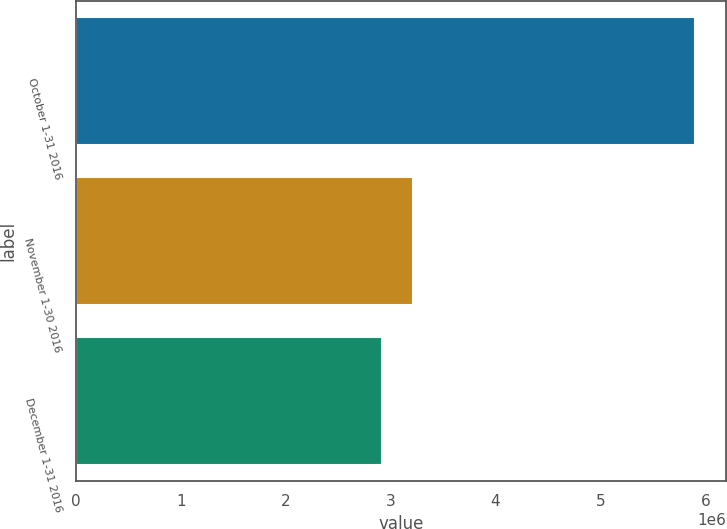Convert chart. <chart><loc_0><loc_0><loc_500><loc_500><bar_chart><fcel>October 1-31 2016<fcel>November 1-30 2016<fcel>December 1-31 2016<nl><fcel>5.90257e+06<fcel>3.21383e+06<fcel>2.91508e+06<nl></chart> 